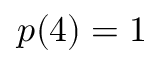Convert formula to latex. <formula><loc_0><loc_0><loc_500><loc_500>p ( 4 ) = 1</formula> 